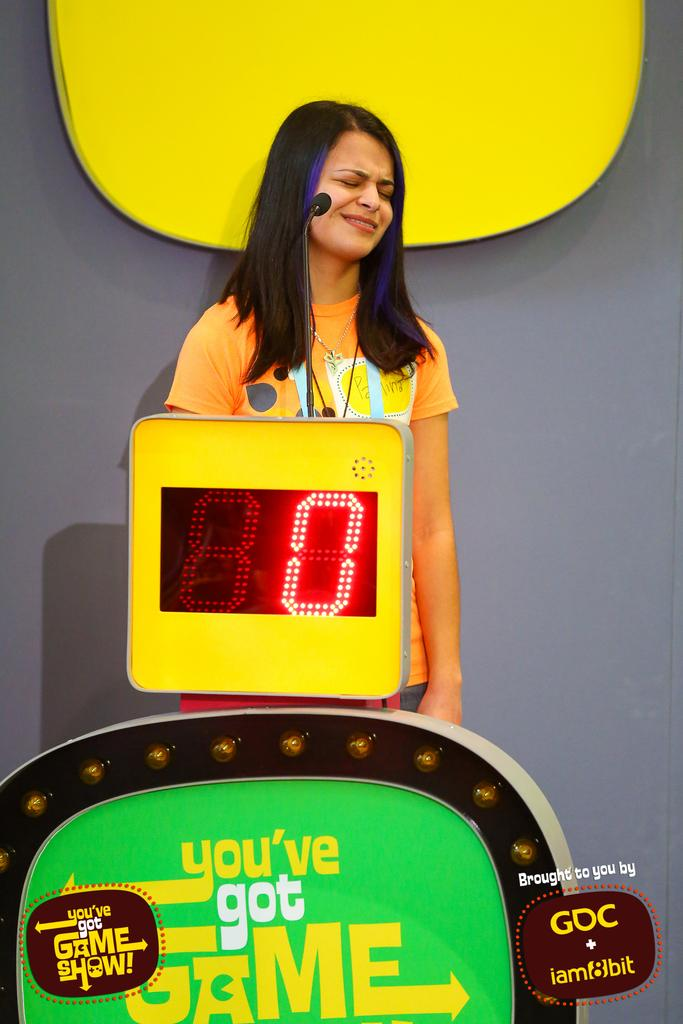What is the main subject in the image? There is a woman standing in the image. What electronic device is present in the image? There is a microphone on an electronic device in the image. What is located at the bottom of the image? There is a board at the bottom of the image. What can be seen on the wall in the background? There is an object on the wall in the background. What is the weight of the duck in the image? There is no duck present in the image, so it is not possible to determine its weight. 